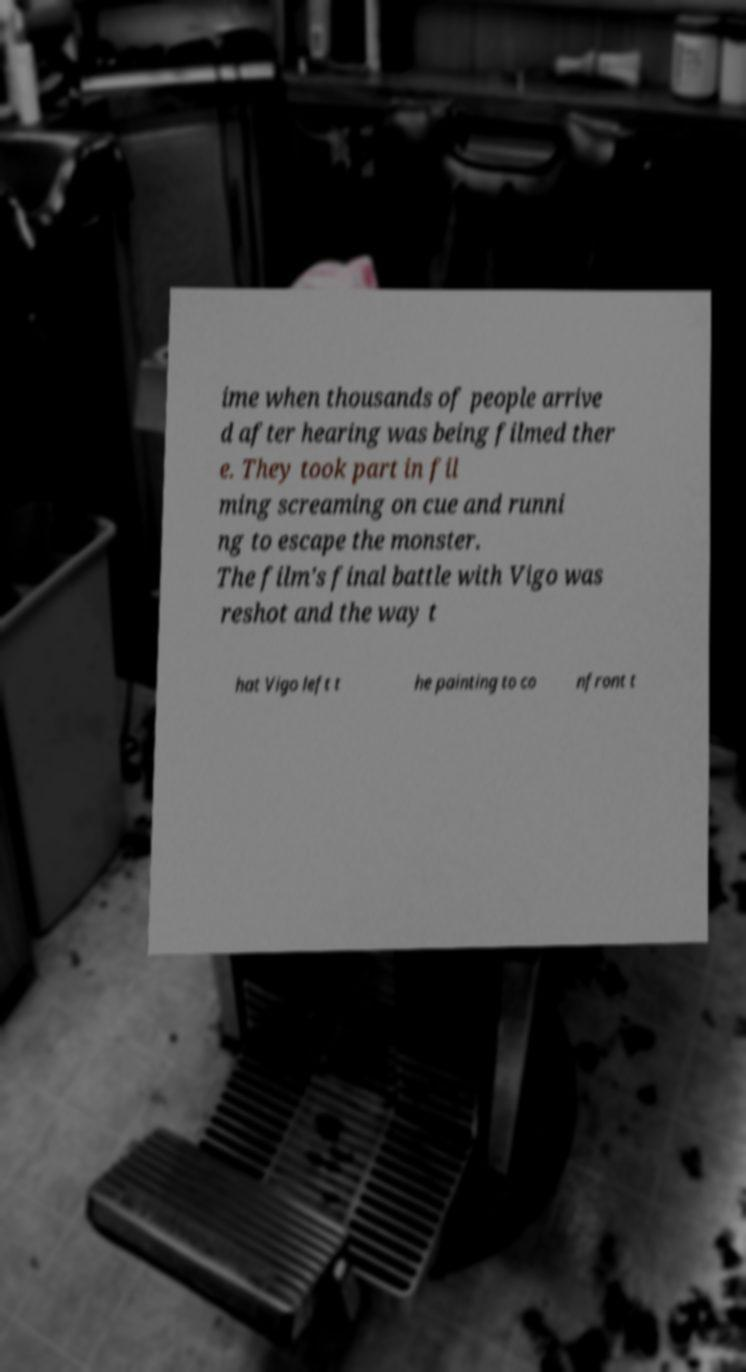What messages or text are displayed in this image? I need them in a readable, typed format. ime when thousands of people arrive d after hearing was being filmed ther e. They took part in fil ming screaming on cue and runni ng to escape the monster. The film's final battle with Vigo was reshot and the way t hat Vigo left t he painting to co nfront t 